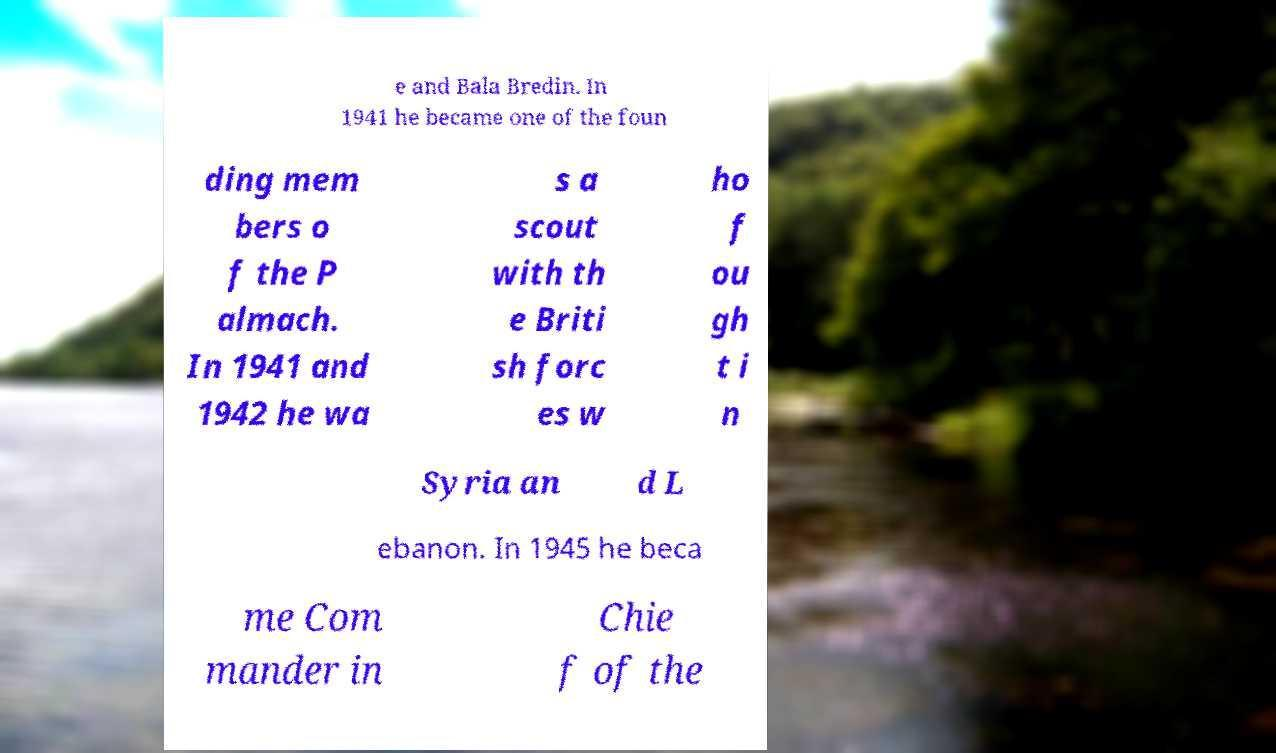What messages or text are displayed in this image? I need them in a readable, typed format. e and Bala Bredin. In 1941 he became one of the foun ding mem bers o f the P almach. In 1941 and 1942 he wa s a scout with th e Briti sh forc es w ho f ou gh t i n Syria an d L ebanon. In 1945 he beca me Com mander in Chie f of the 